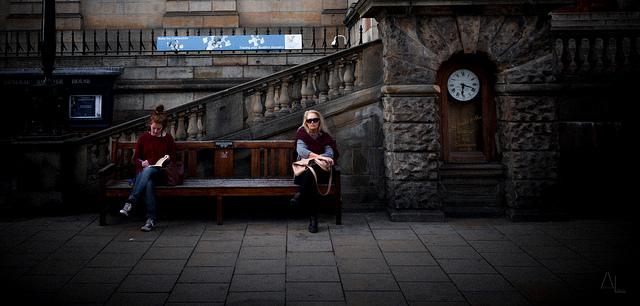What time does the clock say?
Give a very brief answer. 6:20. What are the people doing?
Keep it brief. Sitting. Are these people married?
Write a very short answer. No. Is this an airport?
Keep it brief. No. What are both people doing?
Write a very short answer. Sitting. How many people are in the photo?
Keep it brief. 2. How many people are there?
Concise answer only. 2. Is this in front of a fast food place?
Give a very brief answer. No. 